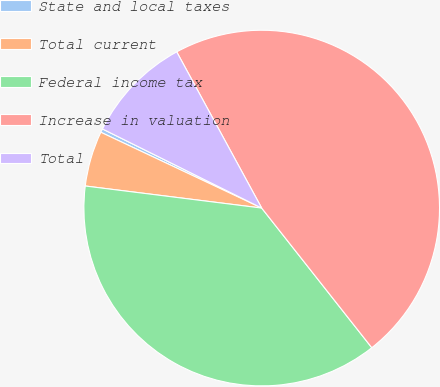Convert chart to OTSL. <chart><loc_0><loc_0><loc_500><loc_500><pie_chart><fcel>State and local taxes<fcel>Total current<fcel>Federal income tax<fcel>Increase in valuation<fcel>Total<nl><fcel>0.33%<fcel>5.03%<fcel>37.61%<fcel>47.31%<fcel>9.73%<nl></chart> 